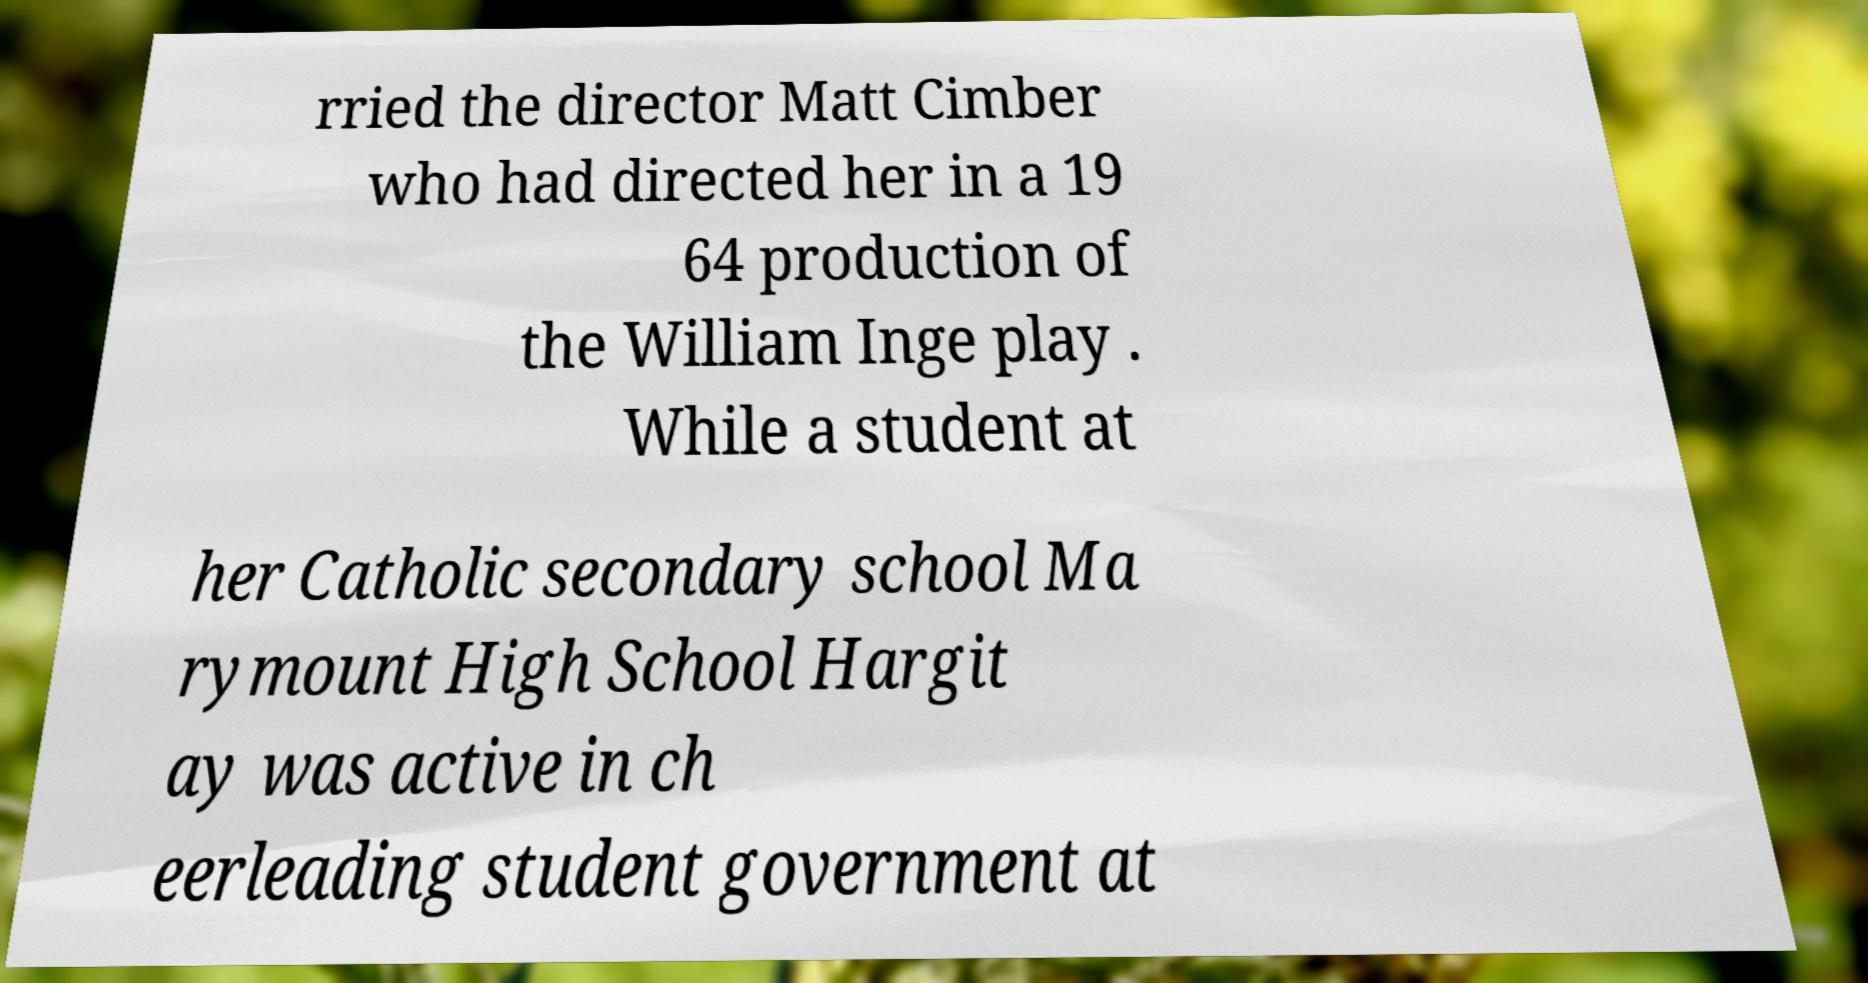Please identify and transcribe the text found in this image. rried the director Matt Cimber who had directed her in a 19 64 production of the William Inge play . While a student at her Catholic secondary school Ma rymount High School Hargit ay was active in ch eerleading student government at 